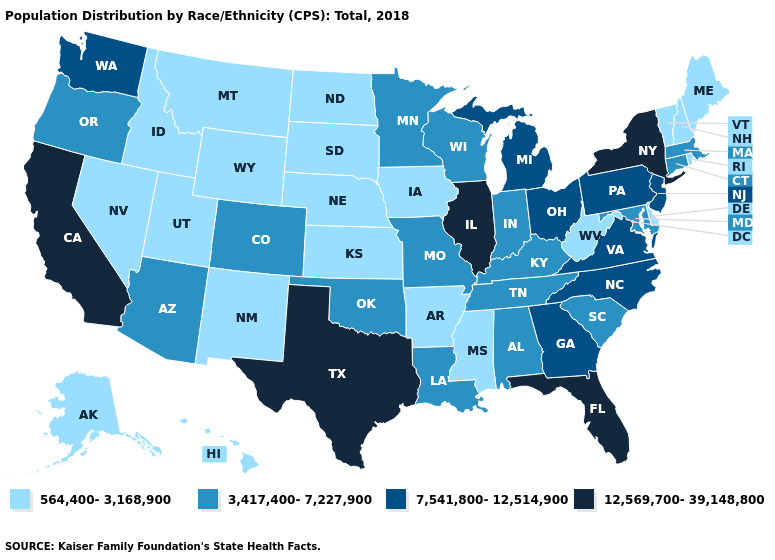Does South Dakota have the lowest value in the MidWest?
Concise answer only. Yes. What is the lowest value in the USA?
Give a very brief answer. 564,400-3,168,900. Name the states that have a value in the range 7,541,800-12,514,900?
Keep it brief. Georgia, Michigan, New Jersey, North Carolina, Ohio, Pennsylvania, Virginia, Washington. Which states have the lowest value in the USA?
Concise answer only. Alaska, Arkansas, Delaware, Hawaii, Idaho, Iowa, Kansas, Maine, Mississippi, Montana, Nebraska, Nevada, New Hampshire, New Mexico, North Dakota, Rhode Island, South Dakota, Utah, Vermont, West Virginia, Wyoming. Among the states that border Iowa , which have the highest value?
Write a very short answer. Illinois. Among the states that border Illinois , does Indiana have the highest value?
Keep it brief. Yes. What is the lowest value in states that border New Mexico?
Be succinct. 564,400-3,168,900. Name the states that have a value in the range 7,541,800-12,514,900?
Answer briefly. Georgia, Michigan, New Jersey, North Carolina, Ohio, Pennsylvania, Virginia, Washington. What is the lowest value in the Northeast?
Be succinct. 564,400-3,168,900. What is the value of Rhode Island?
Keep it brief. 564,400-3,168,900. What is the highest value in the USA?
Concise answer only. 12,569,700-39,148,800. Is the legend a continuous bar?
Keep it brief. No. What is the value of Rhode Island?
Write a very short answer. 564,400-3,168,900. Does Connecticut have the same value as Kentucky?
Concise answer only. Yes. What is the value of West Virginia?
Answer briefly. 564,400-3,168,900. 